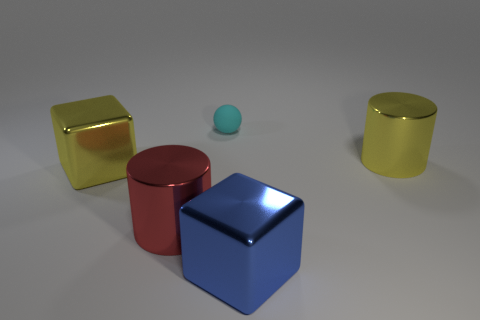How many cubes have the same color as the tiny sphere?
Make the answer very short. 0. Is the shape of the large metallic object in front of the red cylinder the same as the large yellow metal thing that is to the left of the small cyan matte object?
Keep it short and to the point. Yes. There is a large cylinder to the left of the yellow object that is on the right side of the blue block; how many large yellow cylinders are right of it?
Ensure brevity in your answer.  1. There is a big yellow thing that is on the right side of the cube that is in front of the yellow object that is left of the yellow cylinder; what is its material?
Your answer should be compact. Metal. Is the material of the block in front of the red metallic thing the same as the small object?
Your answer should be very brief. No. What number of yellow metallic cubes are the same size as the blue block?
Offer a terse response. 1. Are there more red metallic cylinders that are on the right side of the red cylinder than cyan rubber things that are left of the small cyan matte ball?
Make the answer very short. No. Are there any other red objects of the same shape as the small matte object?
Make the answer very short. No. There is a shiny cylinder in front of the yellow shiny thing to the left of the tiny cyan rubber sphere; what size is it?
Your answer should be very brief. Large. What shape is the big yellow object that is to the left of the cylinder in front of the big yellow metal cylinder behind the yellow block?
Make the answer very short. Cube. 